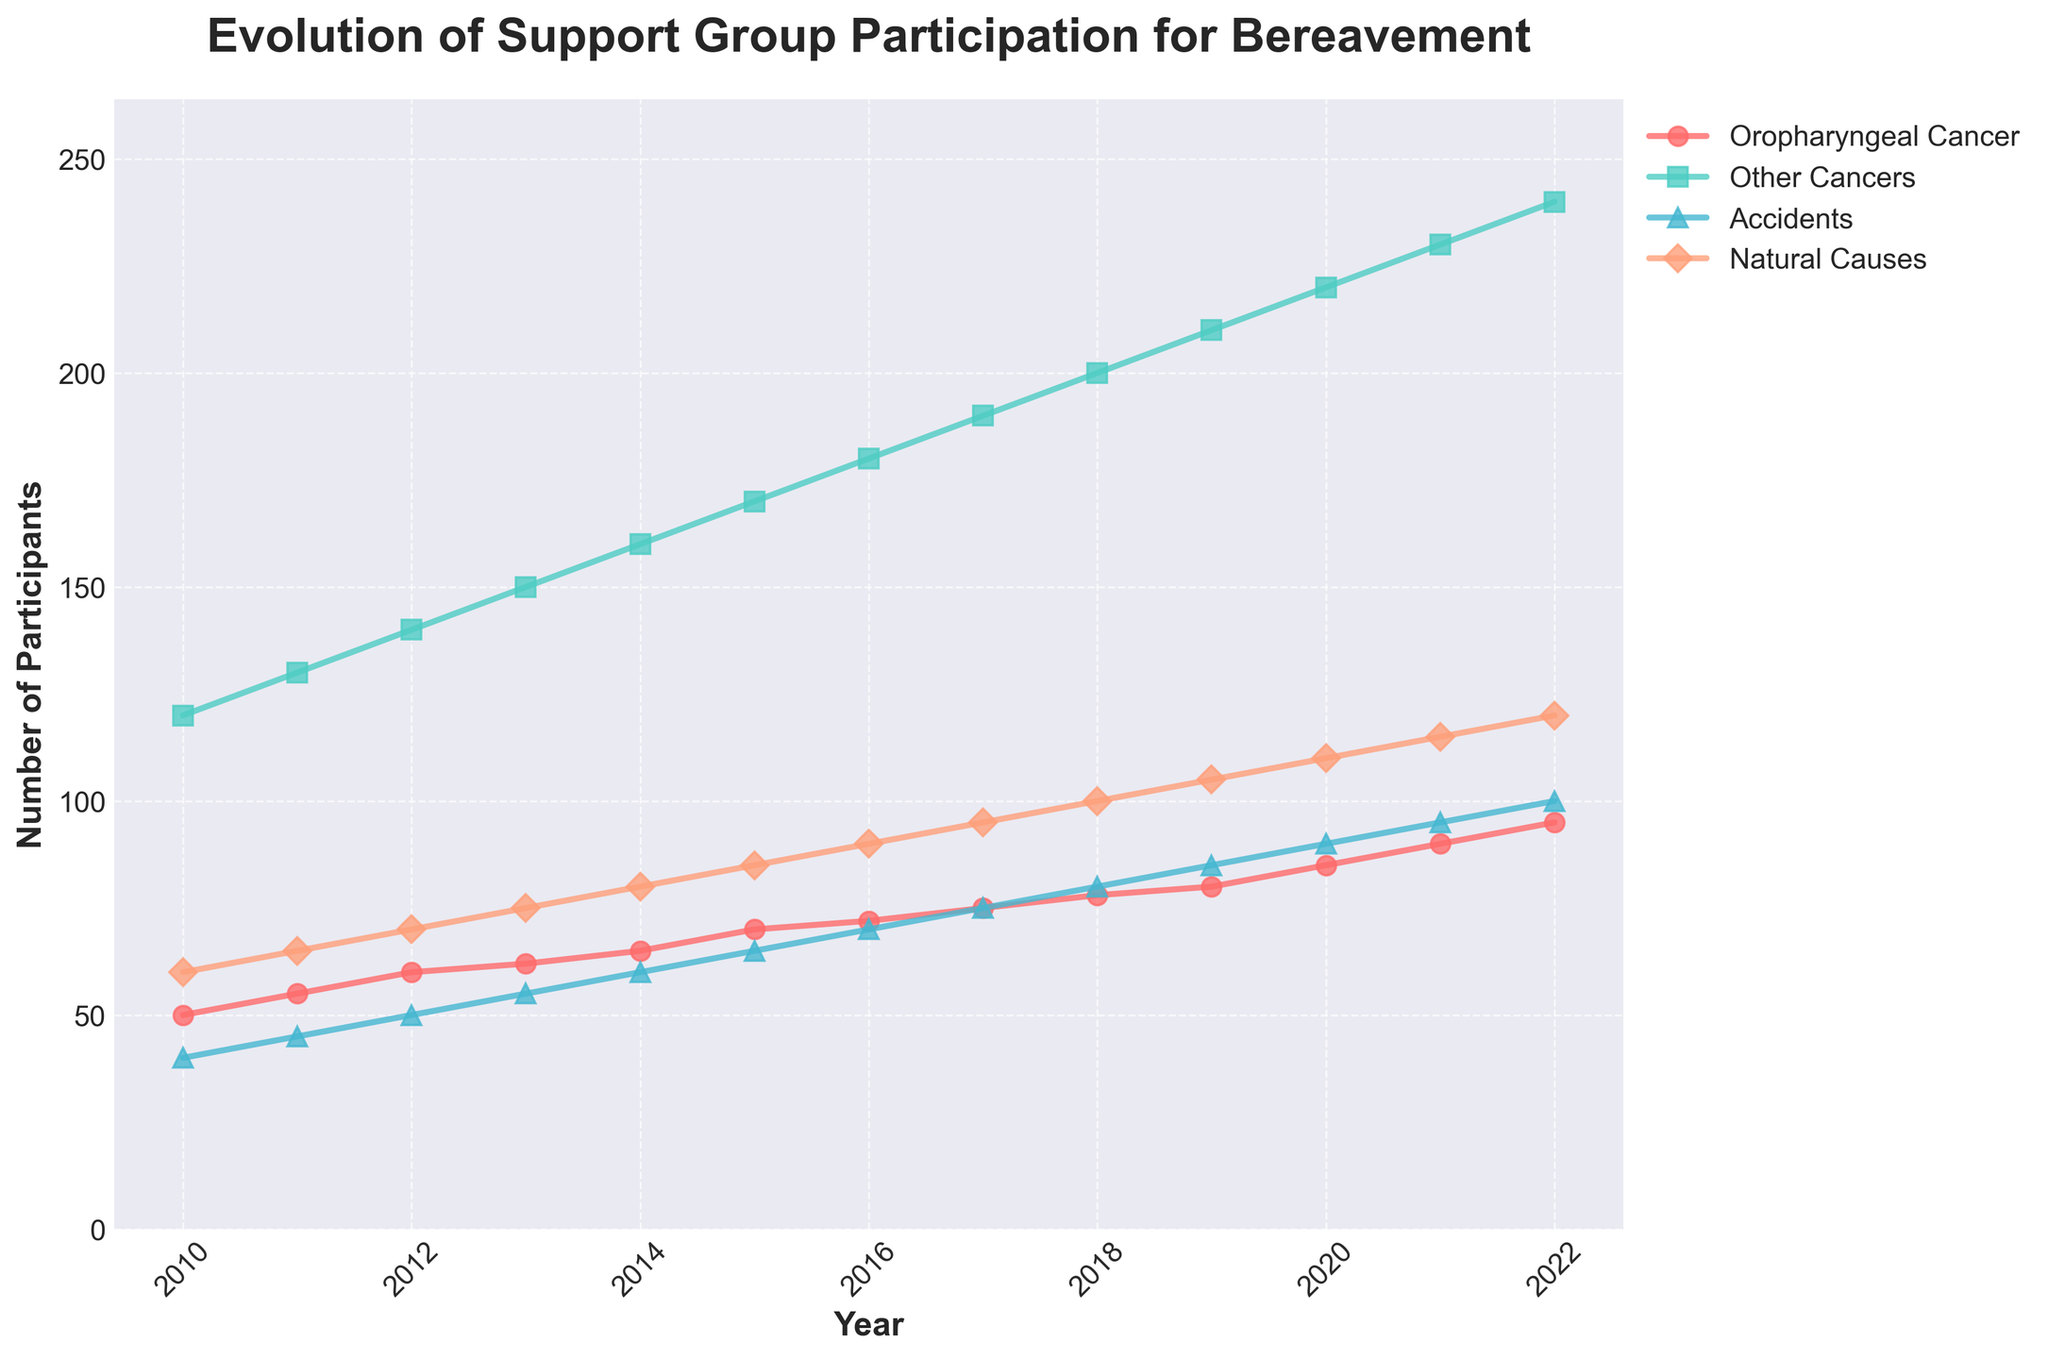what is the title of the plot? The title of the plot is displayed at the top of the figure and summarizes the content of the chart. It reads "Evolution of Support Group Participation for Bereavement".
Answer: Evolution of Support Group Participation for Bereavement What is the range of years represented in the plot? The x-axis of the plot represents the range of years, starting from 2010 to 2022. These labels show the start and end points.
Answer: 2010 to 2022 What color is used for the "Participants Related to Oropharyngeal Cancer"? The plot uses specific colors for each category of participants, and the line representing "Participants Related to Oropharyngeal Cancer" is shown in a specific color which is red.
Answer: Red By how many participants did the "Participants Related to Other Cancers" group increase from 2010 to 2022? The number of participants related to other cancers in 2010 is 120 and in 2022 is 240. To find the increase, subtract the 2010 number from the 2022 number: 240 - 120.
Answer: 120 What is the overall trend for participants related to oropharyngeal cancer from 2010 to 2022? Observing the line representing participants related to oropharyngeal cancer, we see a general increasing trend over time from 50 participants in 2010 to 95 in 2022.
Answer: Increasing Which group had the highest number of participants in 2022? By comparing the end points of all the lines on the right side of the plot, the "Participants Related to Other Cancers" group had the highest number of participants in 2022 with 240.
Answer: Participants Related to Other Cancers What is the smallest difference in the number of participants between any two consecutive years for participants related to accidents? We need to find the smallest year-to-year change in the number of participants related to accidents. The yearly changes are: (45-40), (50-45), (55-50), (60-55), (65-60), (70-65), (75-70), (80-75), (85-80), (90-85), (95-90), (100-95). The smallest difference is 5 participants.
Answer: 5 What is the average number of participants related to natural causes across the years 2010 to 2020? Summing the participants related to natural causes from 2010 to 2020 gives (60 + 65 + 70 + 75 + 80 + 85 + 90 + 95 + 100 + 105 + 110 = 935). The total number of years is 11, so the average is 935 / 11.
Answer: 85 Which group shows the most consistent increase over the years? Observing the trend lines, the "Participants Related to Other Cancers" group shows the most consistent annual increases, with a steady upward slope from 120 in 2010 to 240 in 2022.
Answer: Participants Related to Other Cancers How many more participants were there in the "Participants Related to Natural Causes" group in 2022 compared to "Participants Related to Oropharyngeal Cancer"? The number of participants related to natural causes in 2022 is 120. For oropharyngeal cancer, it is 95. The difference is 120 - 95.
Answer: 25 